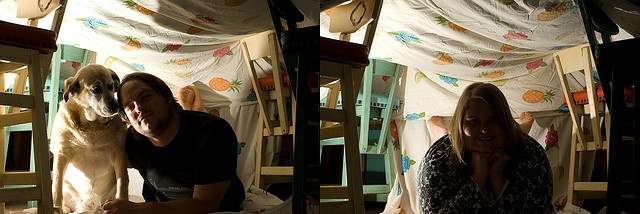Describe the objects in this image and their specific colors. I can see bed in tan, ivory, black, olive, and maroon tones, people in tan, black, maroon, and gray tones, people in tan, black, maroon, and ivory tones, dog in tan, ivory, black, olive, and maroon tones, and chair in tan, black, olive, and ivory tones in this image. 